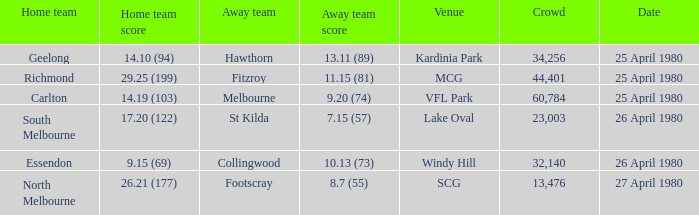What wa the date of the North Melbourne home game? 27 April 1980. 